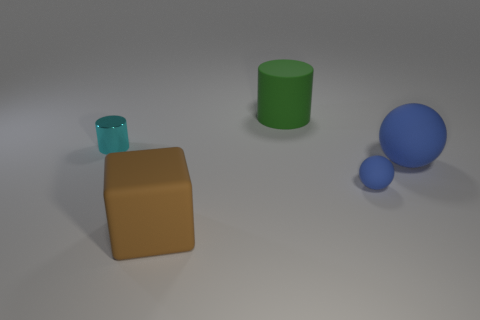Can you tell me if the lighting comes from a particular direction? The lighting in the image appears to come from the upper left side, as suggested by the shadows cast toward the lower right. 